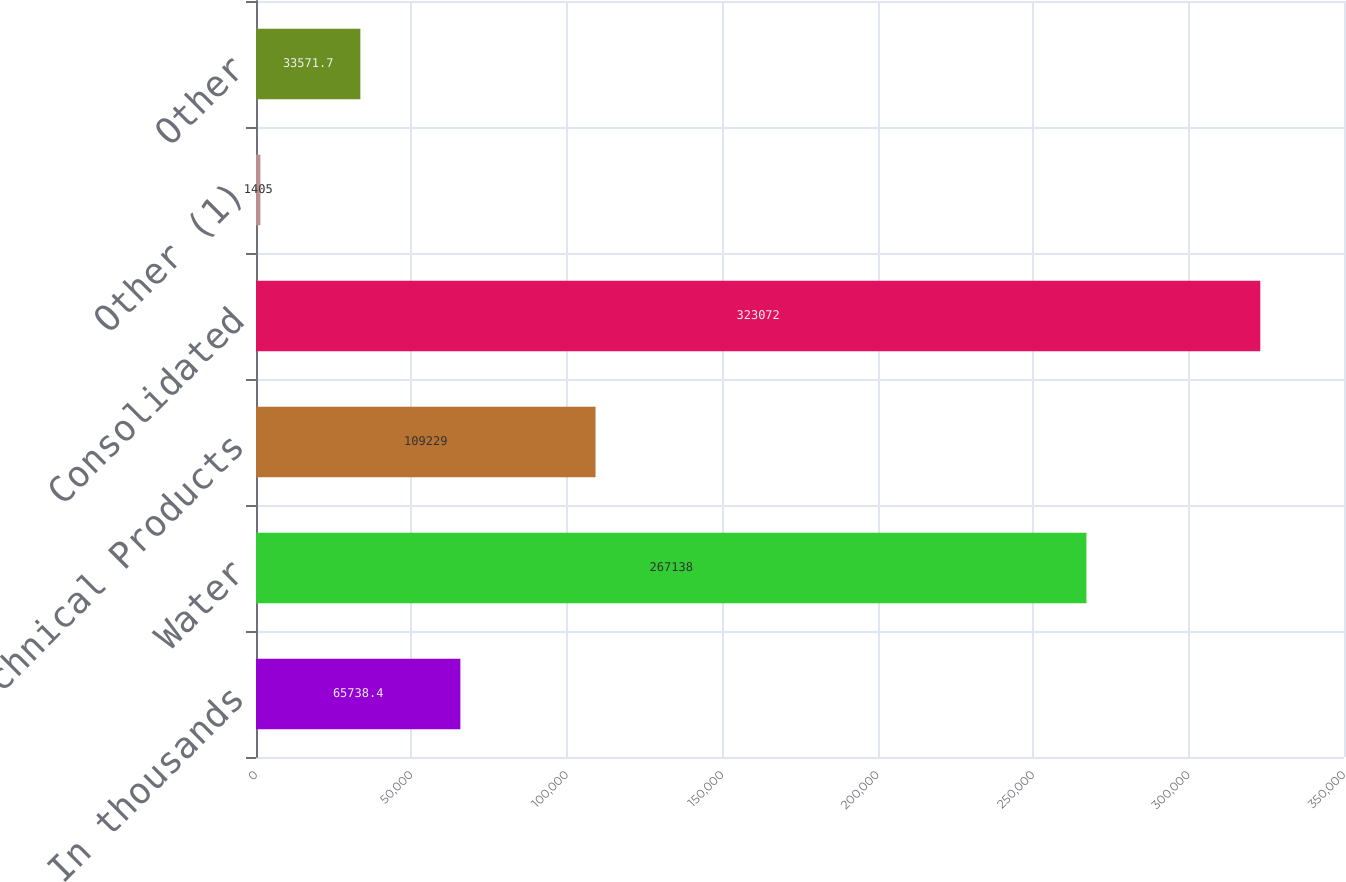Convert chart. <chart><loc_0><loc_0><loc_500><loc_500><bar_chart><fcel>In thousands<fcel>Water<fcel>Technical Products<fcel>Consolidated<fcel>Other (1)<fcel>Other<nl><fcel>65738.4<fcel>267138<fcel>109229<fcel>323072<fcel>1405<fcel>33571.7<nl></chart> 